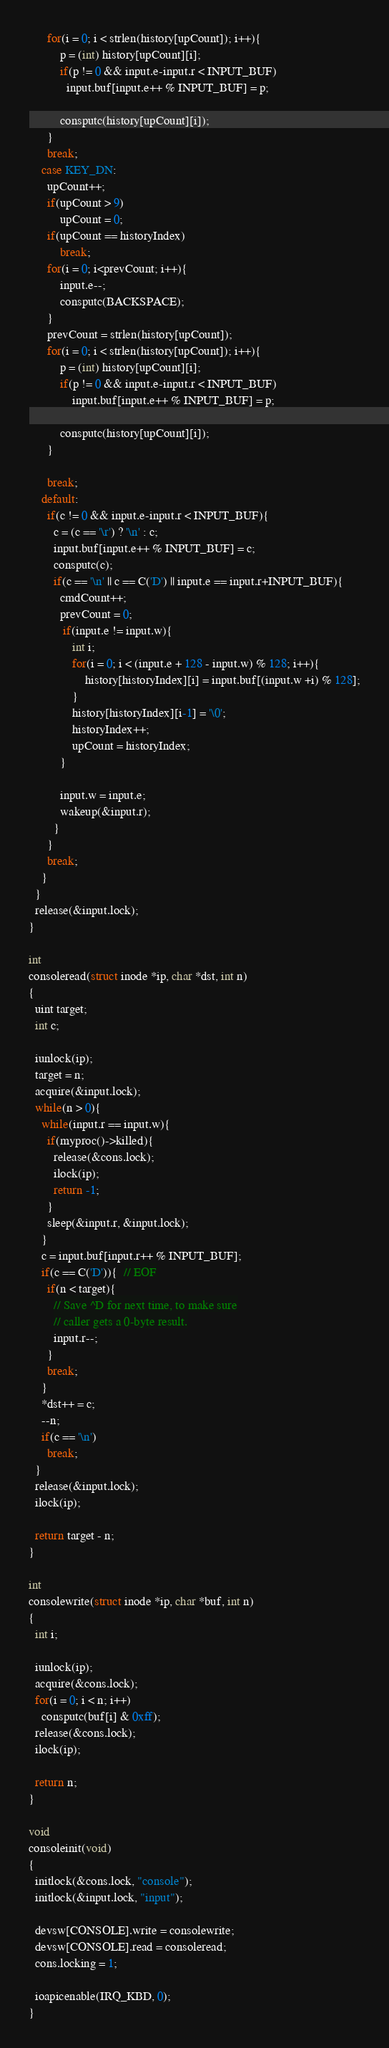<code> <loc_0><loc_0><loc_500><loc_500><_C_>      for(i = 0; i < strlen(history[upCount]); i++){
          p = (int) history[upCount][i];
          if(p != 0 && input.e-input.r < INPUT_BUF)
            input.buf[input.e++ % INPUT_BUF] = p;

          consputc(history[upCount][i]);
      }
      break;
    case KEY_DN:
      upCount++;
      if(upCount > 9)
          upCount = 0;
      if(upCount == historyIndex)
          break;
      for(i = 0; i<prevCount; i++){
          input.e--;
          consputc(BACKSPACE);
      }
      prevCount = strlen(history[upCount]);
      for(i = 0; i < strlen(history[upCount]); i++){
          p = (int) history[upCount][i];
          if(p != 0 && input.e-input.r < INPUT_BUF)
              input.buf[input.e++ % INPUT_BUF] = p;

          consputc(history[upCount][i]);
      }

      break;
    default:
      if(c != 0 && input.e-input.r < INPUT_BUF){
        c = (c == '\r') ? '\n' : c;
        input.buf[input.e++ % INPUT_BUF] = c;
        consputc(c);
        if(c == '\n' || c == C('D') || input.e == input.r+INPUT_BUF){
          cmdCount++;
          prevCount = 0;
           if(input.e != input.w){
              int i;
              for(i = 0; i < (input.e + 128 - input.w) % 128; i++){
                  history[historyIndex][i] = input.buf[(input.w +i) % 128];
              }
              history[historyIndex][i-1] = '\0';
              historyIndex++;
              upCount = historyIndex;
          }
         
          input.w = input.e;
          wakeup(&input.r);
        }
      }
      break;
    }
  }
  release(&input.lock);
}

int
consoleread(struct inode *ip, char *dst, int n)
{
  uint target;
  int c;

  iunlock(ip);
  target = n;
  acquire(&input.lock);
  while(n > 0){
    while(input.r == input.w){
      if(myproc()->killed){
        release(&cons.lock);
        ilock(ip);
        return -1;
      }
      sleep(&input.r, &input.lock);
    }
    c = input.buf[input.r++ % INPUT_BUF];
    if(c == C('D')){  // EOF
      if(n < target){
        // Save ^D for next time, to make sure
        // caller gets a 0-byte result.
        input.r--;
      }
      break;
    }
    *dst++ = c;
    --n;
    if(c == '\n')
      break;
  }
  release(&input.lock);
  ilock(ip);

  return target - n;
}

int
consolewrite(struct inode *ip, char *buf, int n)
{
  int i;

  iunlock(ip);
  acquire(&cons.lock);
  for(i = 0; i < n; i++)
    consputc(buf[i] & 0xff);
  release(&cons.lock);
  ilock(ip);

  return n;
}

void
consoleinit(void)
{
  initlock(&cons.lock, "console");
  initlock(&input.lock, "input");

  devsw[CONSOLE].write = consolewrite;
  devsw[CONSOLE].read = consoleread;
  cons.locking = 1;

  ioapicenable(IRQ_KBD, 0);
}

</code> 